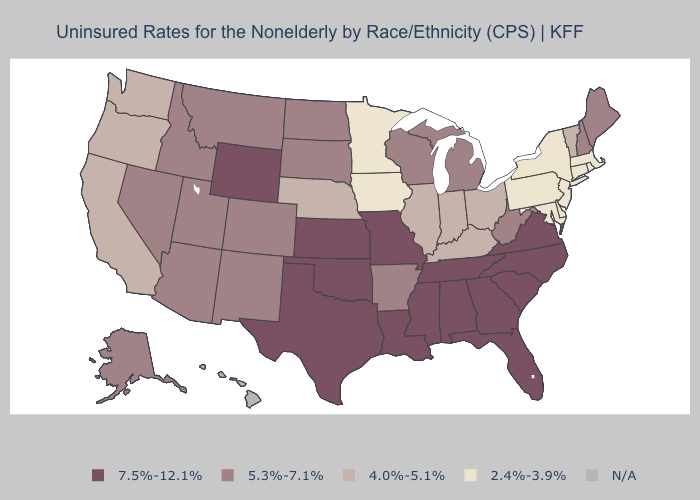Name the states that have a value in the range 5.3%-7.1%?
Keep it brief. Alaska, Arizona, Arkansas, Colorado, Idaho, Maine, Michigan, Montana, Nevada, New Hampshire, New Mexico, North Dakota, South Dakota, Utah, West Virginia, Wisconsin. Which states have the lowest value in the USA?
Answer briefly. Connecticut, Delaware, Iowa, Maryland, Massachusetts, Minnesota, New Jersey, New York, Pennsylvania, Rhode Island. What is the highest value in the USA?
Concise answer only. 7.5%-12.1%. What is the highest value in states that border Maine?
Keep it brief. 5.3%-7.1%. What is the value of Kentucky?
Short answer required. 4.0%-5.1%. What is the highest value in the Northeast ?
Answer briefly. 5.3%-7.1%. What is the highest value in states that border Nebraska?
Write a very short answer. 7.5%-12.1%. Among the states that border Rhode Island , which have the highest value?
Give a very brief answer. Connecticut, Massachusetts. Which states hav the highest value in the MidWest?
Answer briefly. Kansas, Missouri. Among the states that border Louisiana , does Texas have the highest value?
Concise answer only. Yes. What is the value of Nebraska?
Concise answer only. 4.0%-5.1%. Which states have the lowest value in the Northeast?
Answer briefly. Connecticut, Massachusetts, New Jersey, New York, Pennsylvania, Rhode Island. 